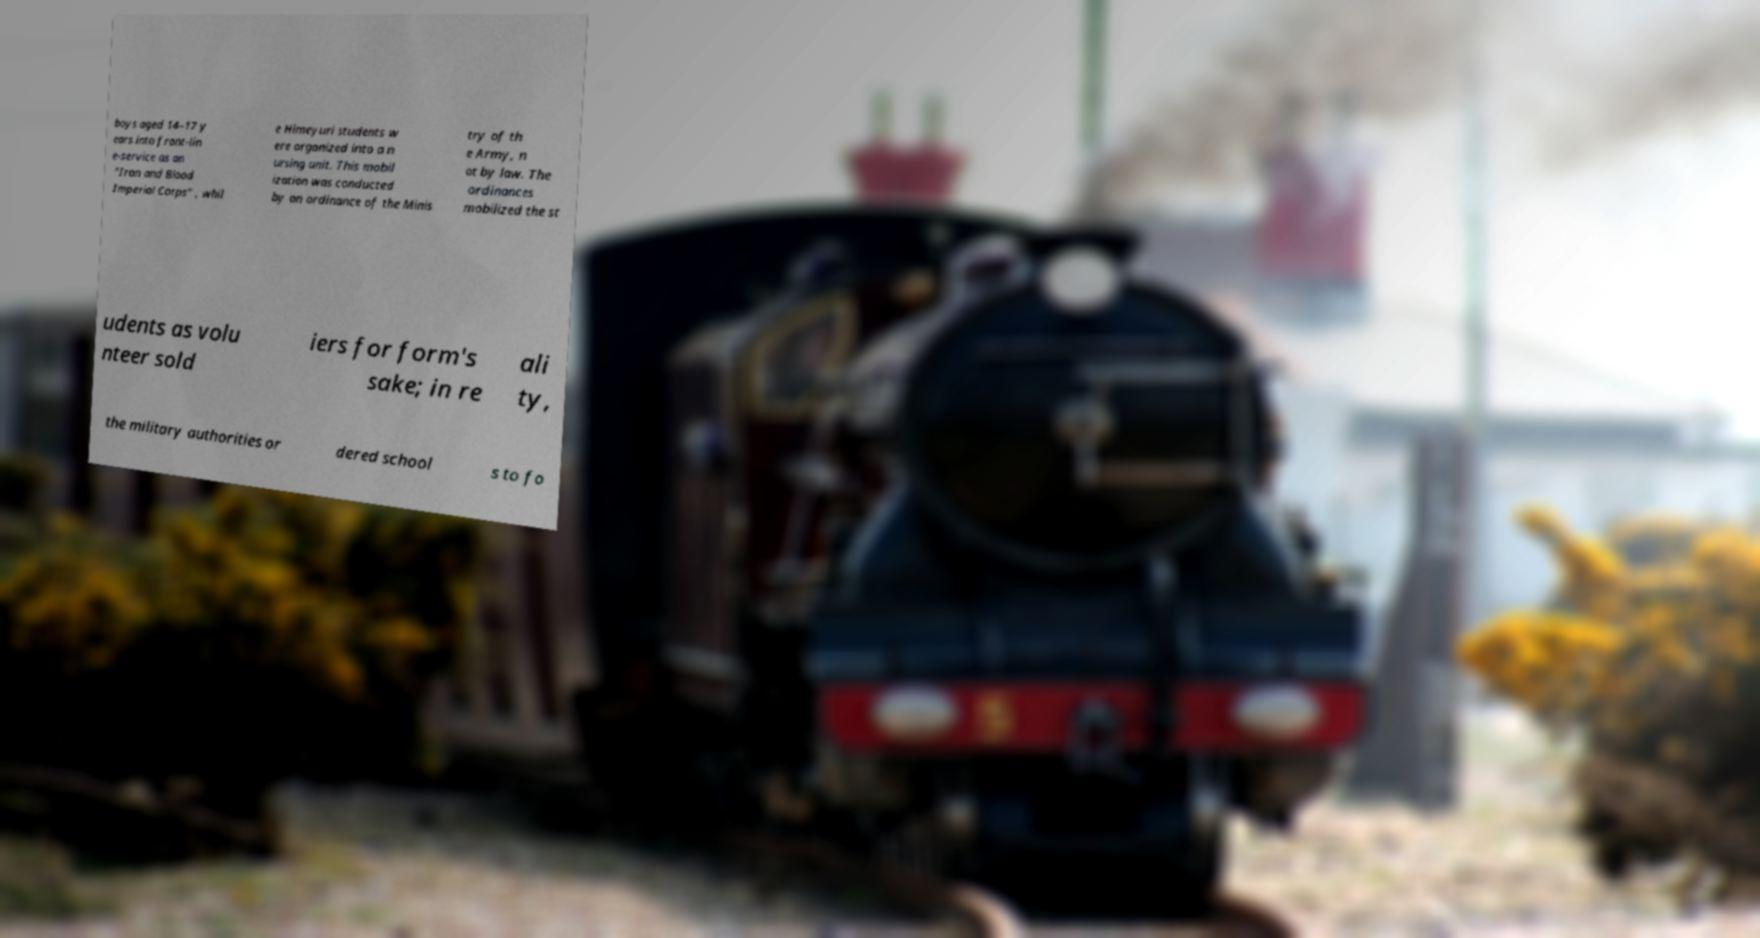Please read and relay the text visible in this image. What does it say? boys aged 14–17 y ears into front-lin e-service as an "Iron and Blood Imperial Corps" , whil e Himeyuri students w ere organized into a n ursing unit. This mobil ization was conducted by an ordinance of the Minis try of th e Army, n ot by law. The ordinances mobilized the st udents as volu nteer sold iers for form's sake; in re ali ty, the military authorities or dered school s to fo 